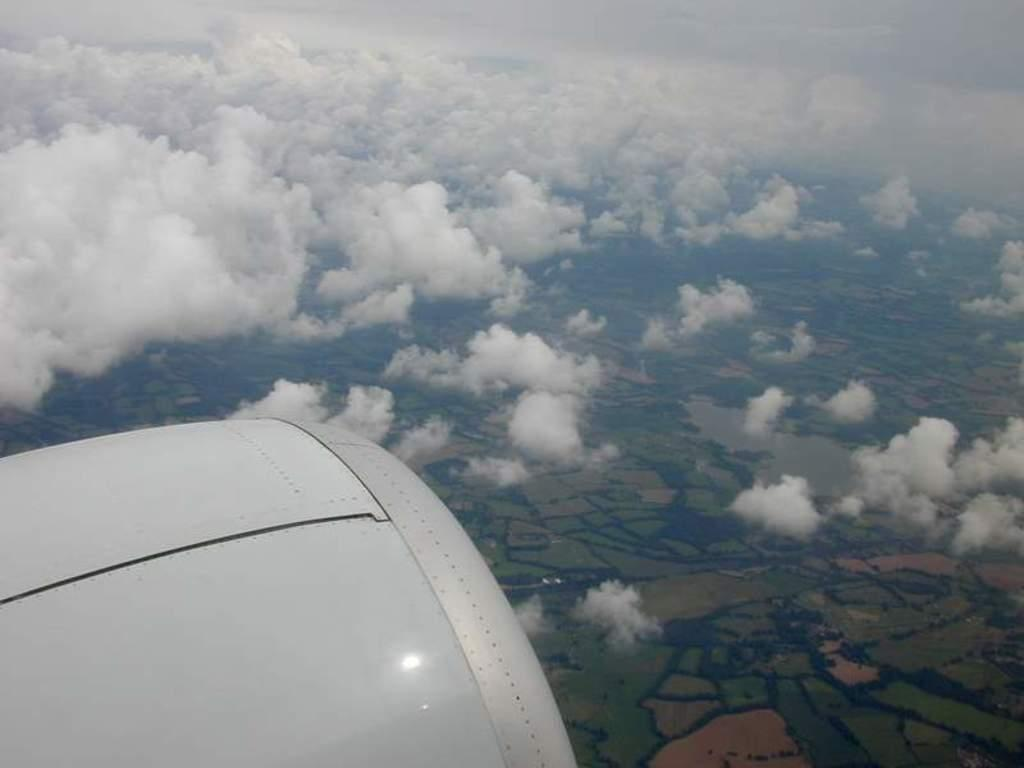What is the condition of the sky in the image? The sky is clouded in the image. What type of vegetation can be seen in the image? There is grass visible in the image. What is the name of the person in the image? There is no person present in the image, so it is not possible to determine their name. How many beds are visible in the image? There are no beds present in the image. Are there any spiders visible in the image? There are no spiders present in the image. 